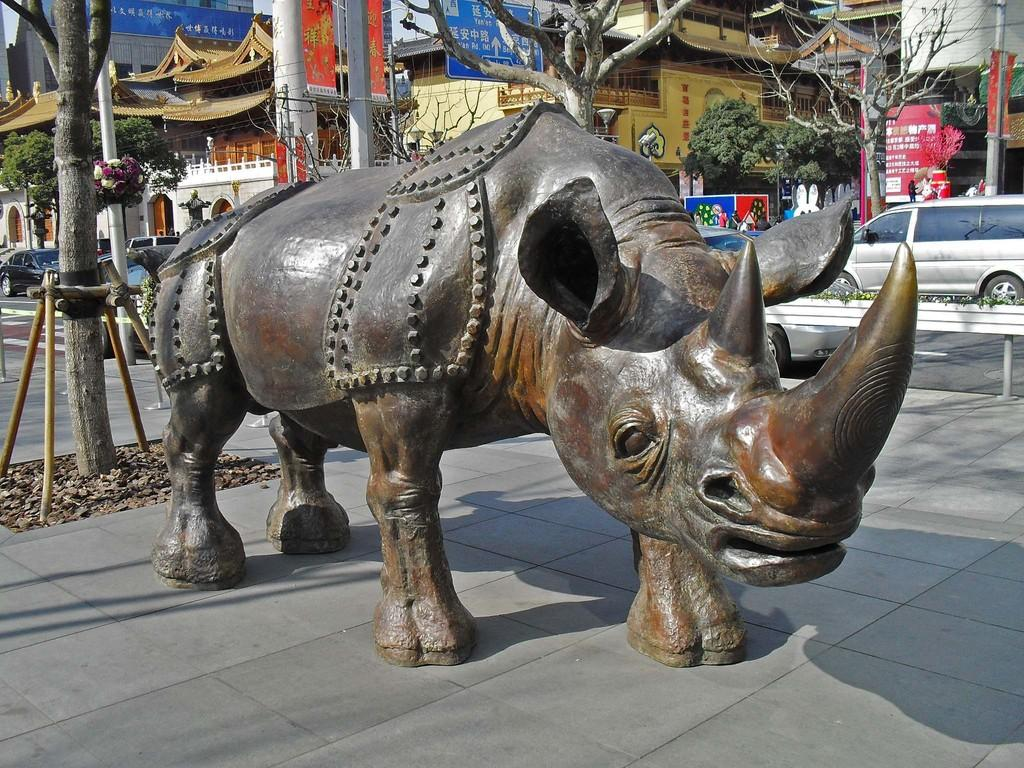What is the main subject of the image? There is a hippopotamus statue in the image. How is the statue positioned in the image? The statue is standing on the ground. What can be seen in the background of the image? There are trees and buildings visible in the background of the image. What mode of transportation is parked on the road in the image? Cars are parked on the road in the image. What type of patch is sewn onto the hippopotamus statue in the image? There is no patch sewn onto the hippopotamus statue in the image. How does the fuel consumption of the cars parked on the road affect the interest rate in the image? There is no information about fuel consumption or interest rates in the image, as it only features a hippopotamus statue, trees, buildings, and parked cars. 